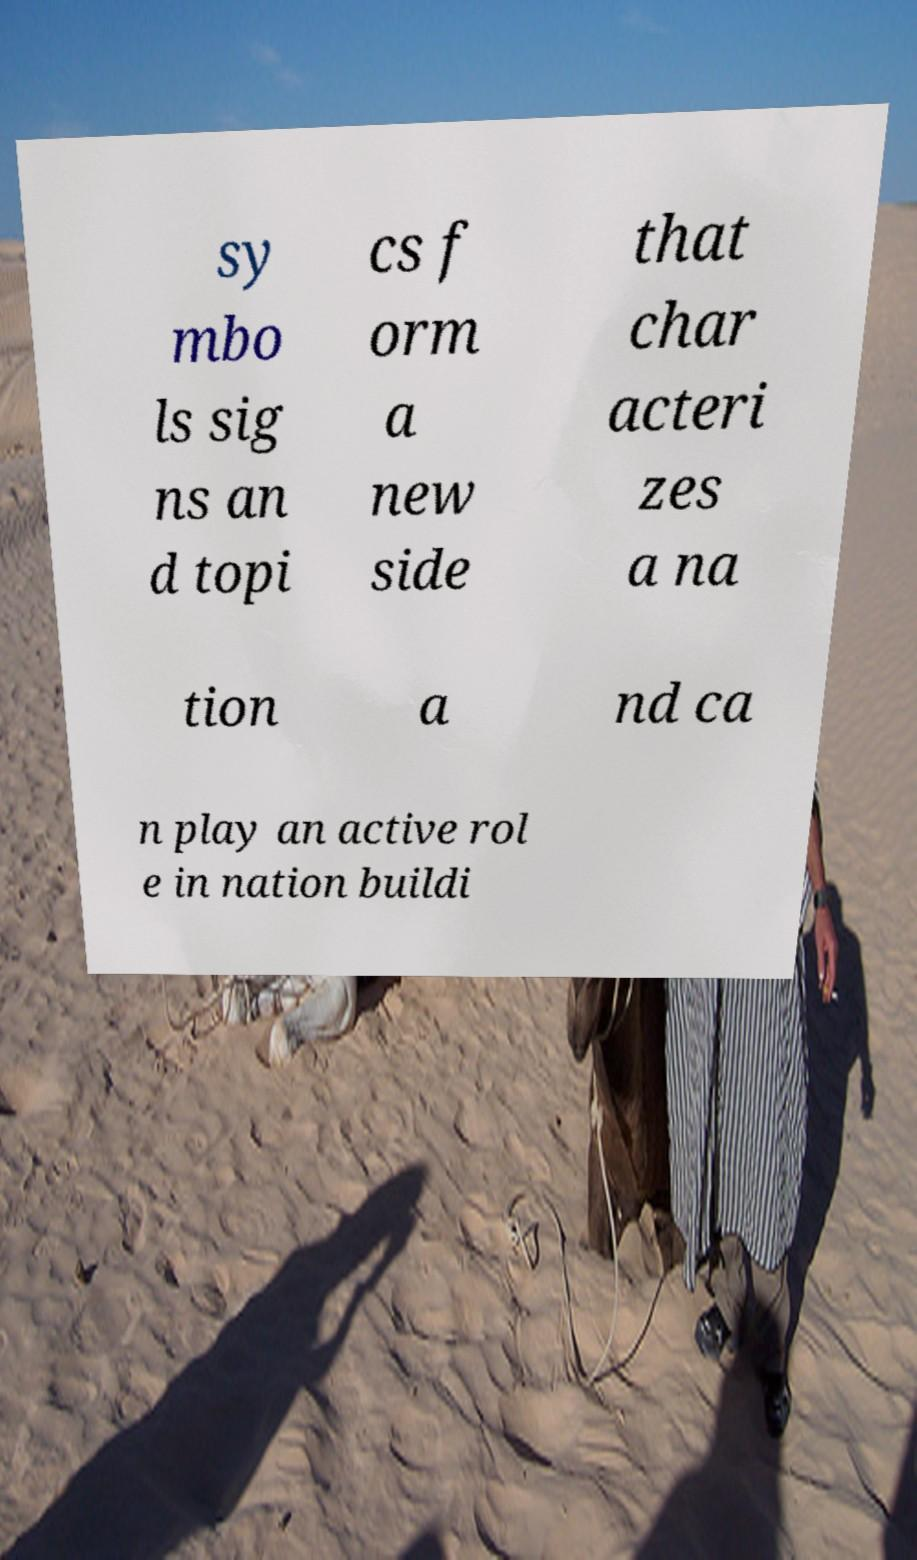Please read and relay the text visible in this image. What does it say? sy mbo ls sig ns an d topi cs f orm a new side that char acteri zes a na tion a nd ca n play an active rol e in nation buildi 